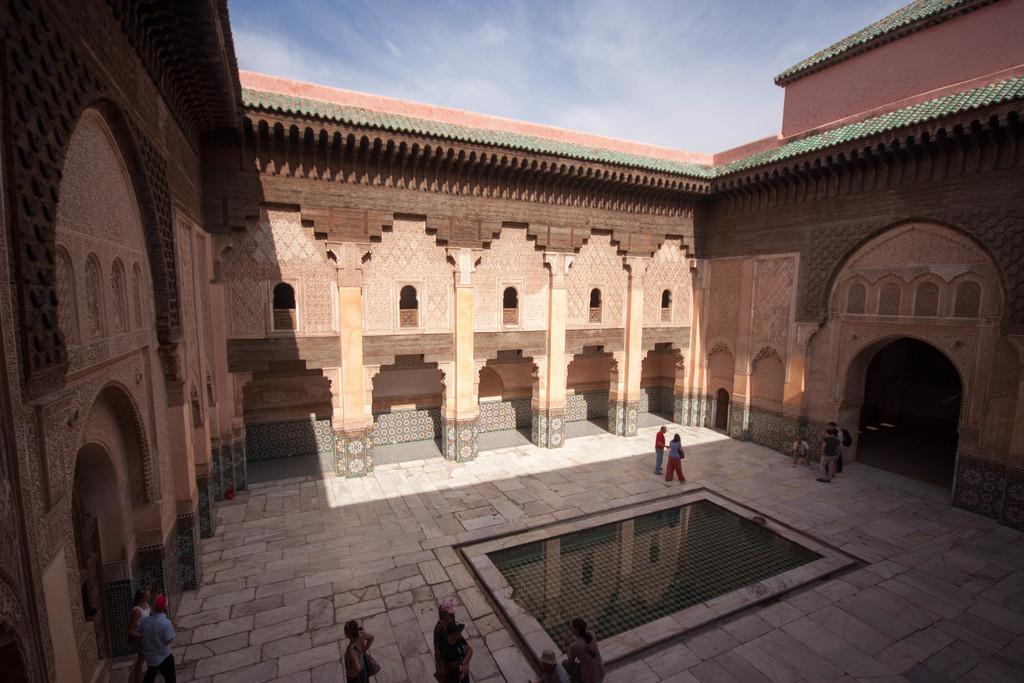Could you give a brief overview of what you see in this image? In this image I can see group of people standing and I can also see the building in brown color. In the background the sky is in blue and white color. 